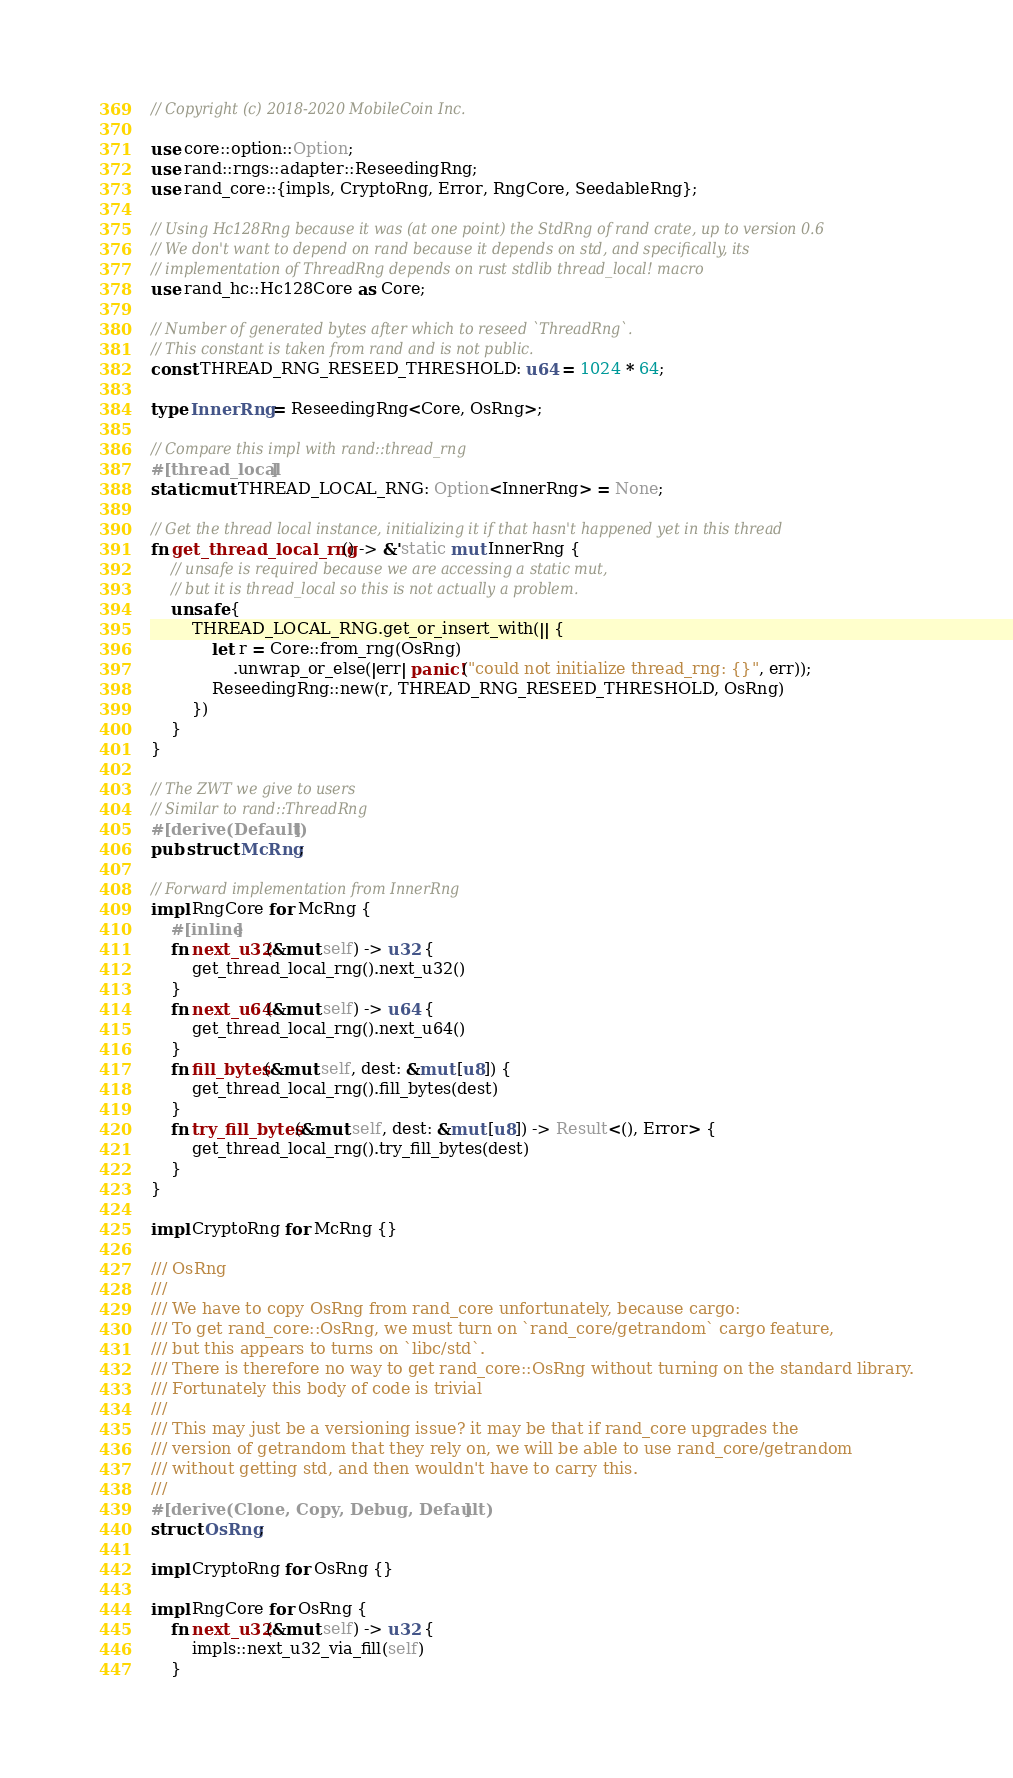Convert code to text. <code><loc_0><loc_0><loc_500><loc_500><_Rust_>// Copyright (c) 2018-2020 MobileCoin Inc.

use core::option::Option;
use rand::rngs::adapter::ReseedingRng;
use rand_core::{impls, CryptoRng, Error, RngCore, SeedableRng};

// Using Hc128Rng because it was (at one point) the StdRng of rand crate, up to version 0.6
// We don't want to depend on rand because it depends on std, and specifically, its
// implementation of ThreadRng depends on rust stdlib thread_local! macro
use rand_hc::Hc128Core as Core;

// Number of generated bytes after which to reseed `ThreadRng`.
// This constant is taken from rand and is not public.
const THREAD_RNG_RESEED_THRESHOLD: u64 = 1024 * 64;

type InnerRng = ReseedingRng<Core, OsRng>;

// Compare this impl with rand::thread_rng
#[thread_local]
static mut THREAD_LOCAL_RNG: Option<InnerRng> = None;

// Get the thread local instance, initializing it if that hasn't happened yet in this thread
fn get_thread_local_rng() -> &'static mut InnerRng {
    // unsafe is required because we are accessing a static mut,
    // but it is thread_local so this is not actually a problem.
    unsafe {
        THREAD_LOCAL_RNG.get_or_insert_with(|| {
            let r = Core::from_rng(OsRng)
                .unwrap_or_else(|err| panic!("could not initialize thread_rng: {}", err));
            ReseedingRng::new(r, THREAD_RNG_RESEED_THRESHOLD, OsRng)
        })
    }
}

// The ZWT we give to users
// Similar to rand::ThreadRng
#[derive(Default)]
pub struct McRng;

// Forward implementation from InnerRng
impl RngCore for McRng {
    #[inline]
    fn next_u32(&mut self) -> u32 {
        get_thread_local_rng().next_u32()
    }
    fn next_u64(&mut self) -> u64 {
        get_thread_local_rng().next_u64()
    }
    fn fill_bytes(&mut self, dest: &mut [u8]) {
        get_thread_local_rng().fill_bytes(dest)
    }
    fn try_fill_bytes(&mut self, dest: &mut [u8]) -> Result<(), Error> {
        get_thread_local_rng().try_fill_bytes(dest)
    }
}

impl CryptoRng for McRng {}

/// OsRng
///
/// We have to copy OsRng from rand_core unfortunately, because cargo:
/// To get rand_core::OsRng, we must turn on `rand_core/getrandom` cargo feature,
/// but this appears to turns on `libc/std`.
/// There is therefore no way to get rand_core::OsRng without turning on the standard library.
/// Fortunately this body of code is trivial
///
/// This may just be a versioning issue? it may be that if rand_core upgrades the
/// version of getrandom that they rely on, we will be able to use rand_core/getrandom
/// without getting std, and then wouldn't have to carry this.
///
#[derive(Clone, Copy, Debug, Default)]
struct OsRng;

impl CryptoRng for OsRng {}

impl RngCore for OsRng {
    fn next_u32(&mut self) -> u32 {
        impls::next_u32_via_fill(self)
    }
</code> 